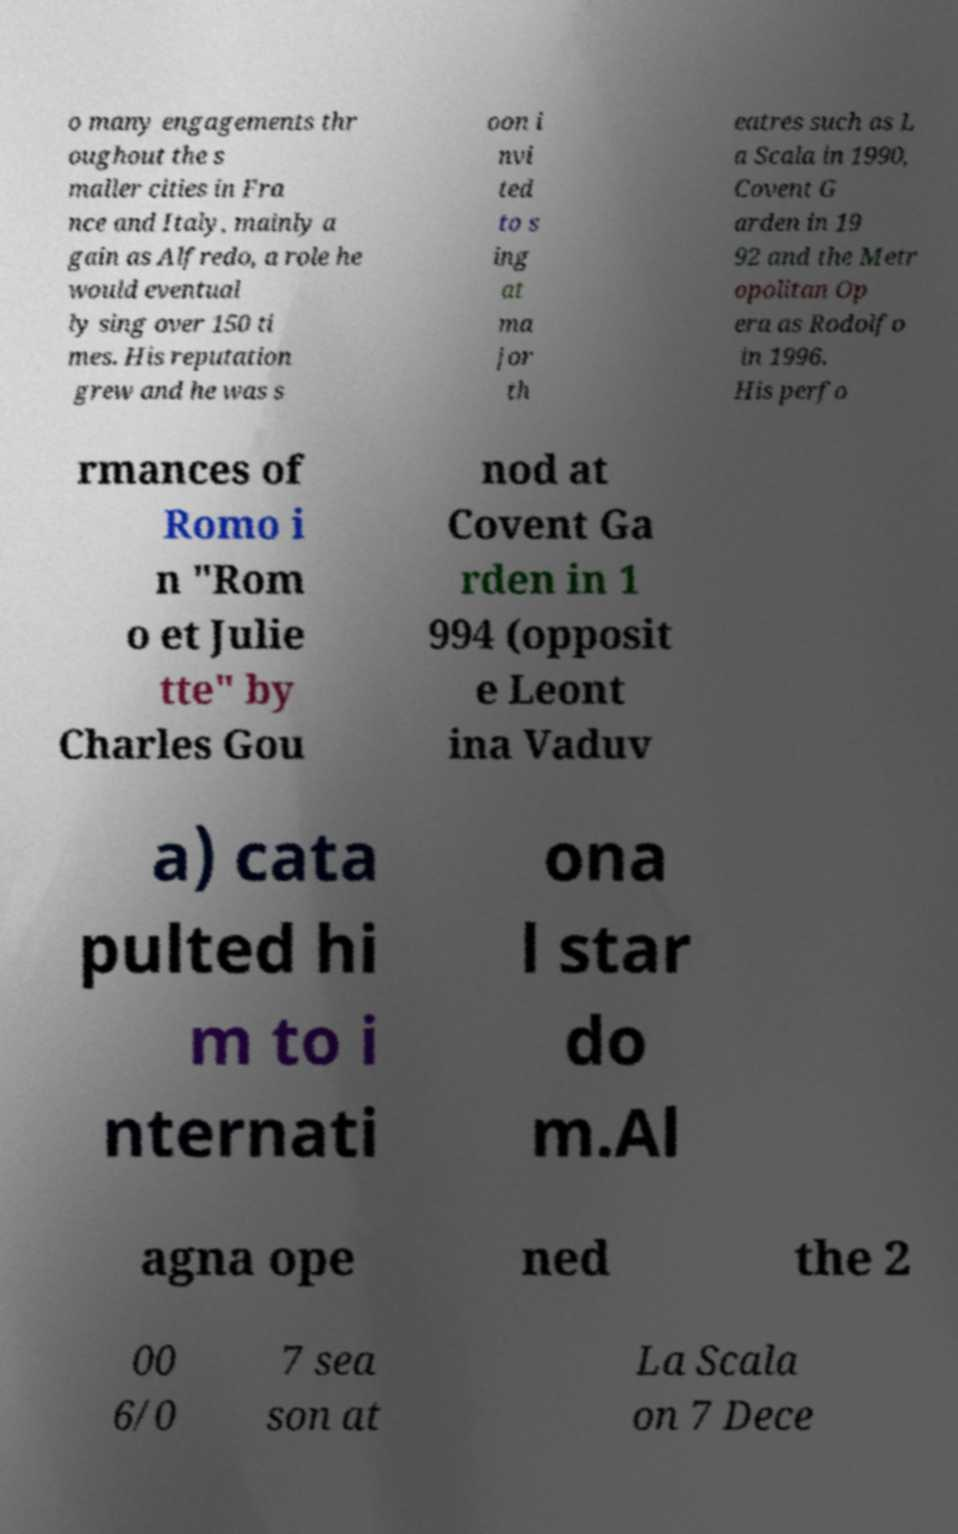Can you read and provide the text displayed in the image?This photo seems to have some interesting text. Can you extract and type it out for me? o many engagements thr oughout the s maller cities in Fra nce and Italy, mainly a gain as Alfredo, a role he would eventual ly sing over 150 ti mes. His reputation grew and he was s oon i nvi ted to s ing at ma jor th eatres such as L a Scala in 1990, Covent G arden in 19 92 and the Metr opolitan Op era as Rodolfo in 1996. His perfo rmances of Romo i n "Rom o et Julie tte" by Charles Gou nod at Covent Ga rden in 1 994 (opposit e Leont ina Vaduv a) cata pulted hi m to i nternati ona l star do m.Al agna ope ned the 2 00 6/0 7 sea son at La Scala on 7 Dece 